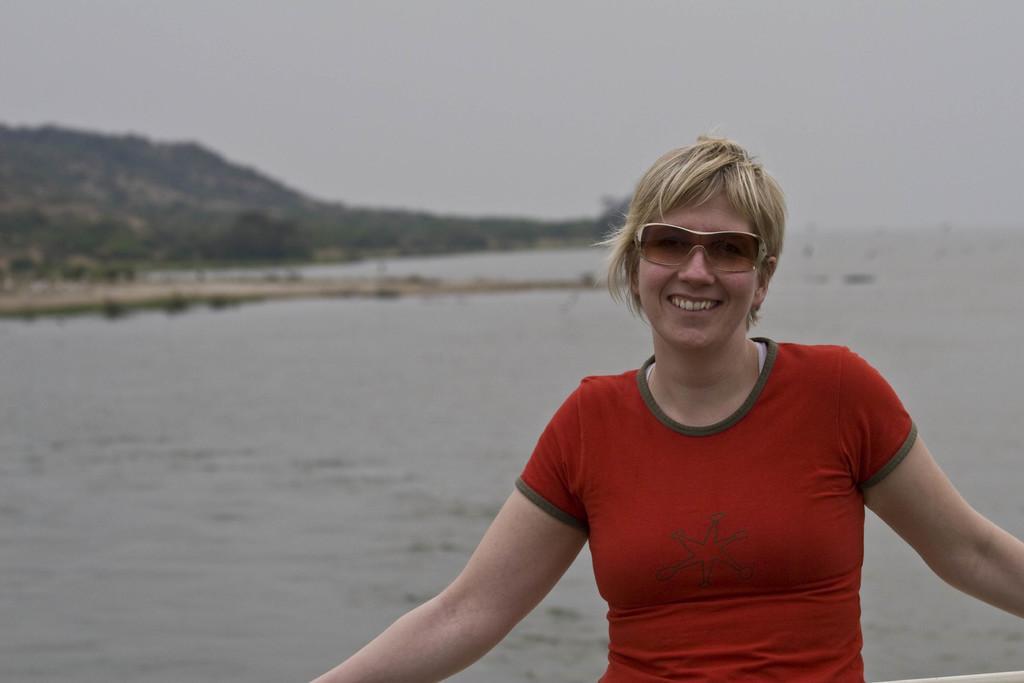In one or two sentences, can you explain what this image depicts? In this image we can see a woman standing. On the backside we can see a large water body, a group of trees, mountains and the sky. 